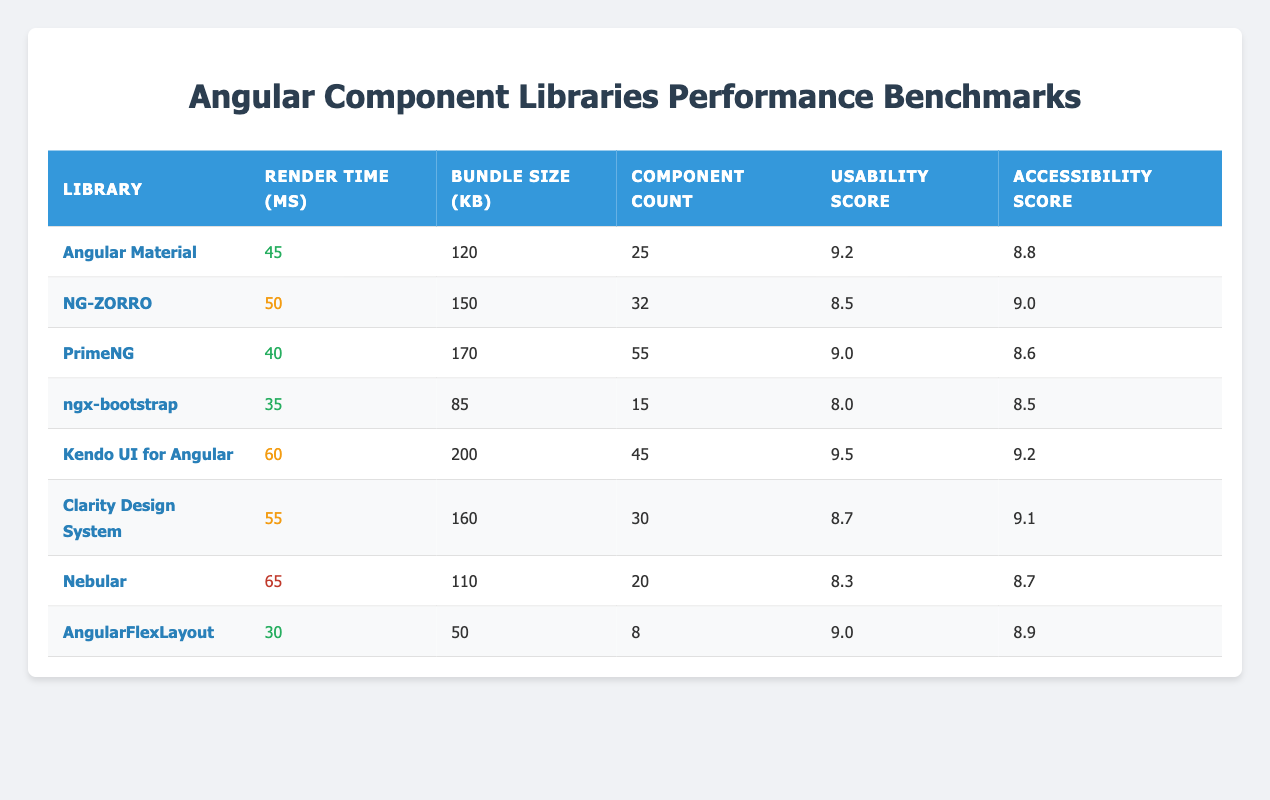What is the render time of PrimeNG? Looking at the row for PrimeNG in the table, the render time is listed under the "Render Time (ms)" column, which shows 40 ms.
Answer: 40 ms Which library has the highest usability score? By examining the usability scores for each library, Kendo UI for Angular has the highest score of 9.5.
Answer: Kendo UI for Angular What is the average bundle size of all libraries? To find the average bundle size, we sum the bundle sizes (120 + 150 + 170 + 85 + 200 + 160 + 110 + 50 = 1,045) and divide by the number of libraries (8). The average is 1,045 / 8 = 130.625.
Answer: 130.625 KB Is Angular Material the fastest library in terms of render time? Comparing the render time of Angular Material (45 ms) with that of other libraries, ngx-bootstrap has a faster render time of 35 ms, which makes Angular Material not the fastest.
Answer: No Which library has the lowest accessibility score? Reviewing the accessibility scores, Nebular has the lowest score of 8.7.
Answer: Nebular 